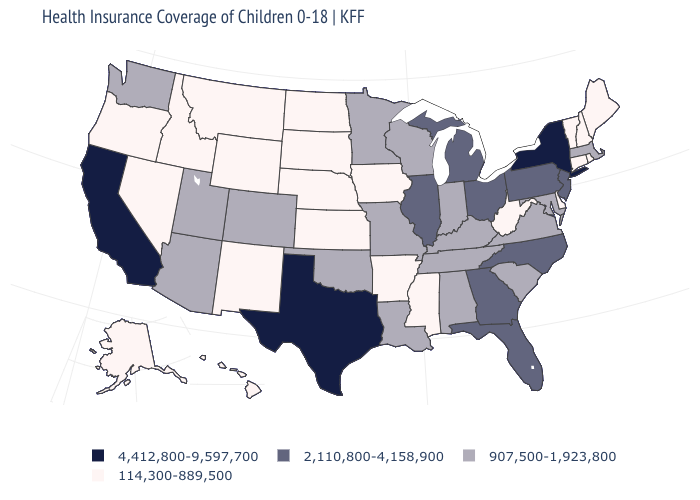What is the lowest value in states that border Connecticut?
Give a very brief answer. 114,300-889,500. Name the states that have a value in the range 4,412,800-9,597,700?
Give a very brief answer. California, New York, Texas. How many symbols are there in the legend?
Quick response, please. 4. What is the value of New Hampshire?
Short answer required. 114,300-889,500. What is the lowest value in states that border Delaware?
Quick response, please. 907,500-1,923,800. Does Maine have the highest value in the Northeast?
Quick response, please. No. Does Delaware have the same value as Ohio?
Be succinct. No. Name the states that have a value in the range 2,110,800-4,158,900?
Answer briefly. Florida, Georgia, Illinois, Michigan, New Jersey, North Carolina, Ohio, Pennsylvania. Name the states that have a value in the range 907,500-1,923,800?
Answer briefly. Alabama, Arizona, Colorado, Indiana, Kentucky, Louisiana, Maryland, Massachusetts, Minnesota, Missouri, Oklahoma, South Carolina, Tennessee, Utah, Virginia, Washington, Wisconsin. What is the lowest value in states that border Nebraska?
Keep it brief. 114,300-889,500. What is the lowest value in the USA?
Write a very short answer. 114,300-889,500. Does New York have the highest value in the Northeast?
Write a very short answer. Yes. 